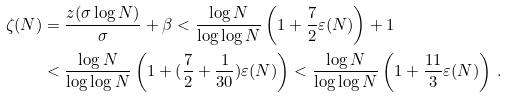<formula> <loc_0><loc_0><loc_500><loc_500>\zeta ( N ) & = \frac { z ( \sigma \log N ) } { \sigma } + \beta < \frac { \log N } { \log \log N } \left ( 1 + \frac { 7 } { 2 } \varepsilon ( N ) \right ) + 1 \\ & < \frac { \log N } { \log \log N } \left ( 1 + ( \frac { 7 } { 2 } + \frac { 1 } { 3 0 } ) \varepsilon ( N ) \right ) < \frac { \log N } { \log \log N } \left ( 1 + \frac { 1 1 } { 3 } \varepsilon ( N ) \right ) \, .</formula> 